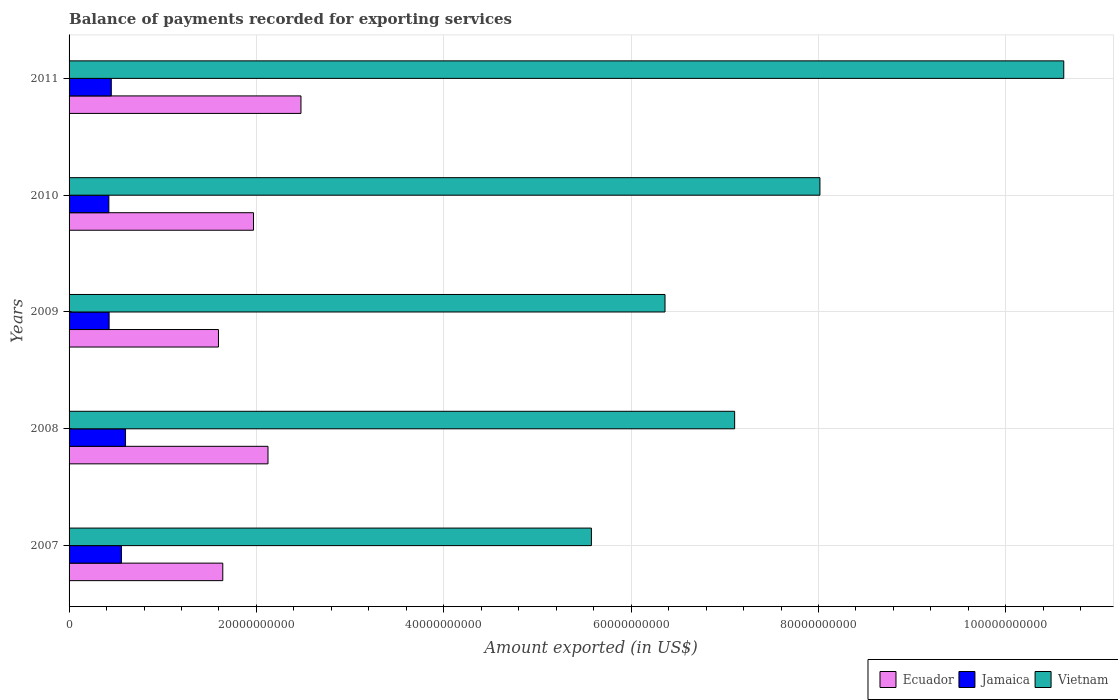How many different coloured bars are there?
Keep it short and to the point. 3. How many groups of bars are there?
Make the answer very short. 5. Are the number of bars on each tick of the Y-axis equal?
Provide a short and direct response. Yes. How many bars are there on the 3rd tick from the bottom?
Provide a succinct answer. 3. In how many cases, is the number of bars for a given year not equal to the number of legend labels?
Give a very brief answer. 0. What is the amount exported in Vietnam in 2011?
Make the answer very short. 1.06e+11. Across all years, what is the maximum amount exported in Ecuador?
Ensure brevity in your answer.  2.48e+1. Across all years, what is the minimum amount exported in Vietnam?
Provide a short and direct response. 5.58e+1. In which year was the amount exported in Ecuador maximum?
Provide a short and direct response. 2011. What is the total amount exported in Vietnam in the graph?
Offer a very short reply. 3.77e+11. What is the difference between the amount exported in Jamaica in 2008 and that in 2010?
Offer a very short reply. 1.78e+09. What is the difference between the amount exported in Ecuador in 2008 and the amount exported in Vietnam in 2007?
Provide a succinct answer. -3.45e+1. What is the average amount exported in Ecuador per year?
Offer a terse response. 1.96e+1. In the year 2009, what is the difference between the amount exported in Vietnam and amount exported in Ecuador?
Offer a terse response. 4.77e+1. What is the ratio of the amount exported in Jamaica in 2009 to that in 2010?
Your answer should be very brief. 1.01. Is the amount exported in Jamaica in 2009 less than that in 2011?
Ensure brevity in your answer.  Yes. Is the difference between the amount exported in Vietnam in 2009 and 2010 greater than the difference between the amount exported in Ecuador in 2009 and 2010?
Ensure brevity in your answer.  No. What is the difference between the highest and the second highest amount exported in Vietnam?
Your answer should be very brief. 2.60e+1. What is the difference between the highest and the lowest amount exported in Ecuador?
Provide a succinct answer. 8.81e+09. What does the 2nd bar from the top in 2011 represents?
Make the answer very short. Jamaica. What does the 3rd bar from the bottom in 2008 represents?
Make the answer very short. Vietnam. Is it the case that in every year, the sum of the amount exported in Ecuador and amount exported in Vietnam is greater than the amount exported in Jamaica?
Your response must be concise. Yes. How many bars are there?
Provide a succinct answer. 15. What is the difference between two consecutive major ticks on the X-axis?
Offer a terse response. 2.00e+1. Are the values on the major ticks of X-axis written in scientific E-notation?
Your response must be concise. No. Does the graph contain grids?
Provide a short and direct response. Yes. How many legend labels are there?
Provide a short and direct response. 3. How are the legend labels stacked?
Your response must be concise. Horizontal. What is the title of the graph?
Give a very brief answer. Balance of payments recorded for exporting services. What is the label or title of the X-axis?
Give a very brief answer. Amount exported (in US$). What is the label or title of the Y-axis?
Offer a very short reply. Years. What is the Amount exported (in US$) of Ecuador in 2007?
Ensure brevity in your answer.  1.64e+1. What is the Amount exported (in US$) in Jamaica in 2007?
Give a very brief answer. 5.59e+09. What is the Amount exported (in US$) in Vietnam in 2007?
Ensure brevity in your answer.  5.58e+1. What is the Amount exported (in US$) of Ecuador in 2008?
Offer a very short reply. 2.12e+1. What is the Amount exported (in US$) of Jamaica in 2008?
Provide a succinct answer. 6.03e+09. What is the Amount exported (in US$) of Vietnam in 2008?
Your answer should be compact. 7.10e+1. What is the Amount exported (in US$) in Ecuador in 2009?
Offer a very short reply. 1.59e+1. What is the Amount exported (in US$) of Jamaica in 2009?
Keep it short and to the point. 4.27e+09. What is the Amount exported (in US$) of Vietnam in 2009?
Keep it short and to the point. 6.36e+1. What is the Amount exported (in US$) of Ecuador in 2010?
Offer a terse response. 1.97e+1. What is the Amount exported (in US$) in Jamaica in 2010?
Your answer should be compact. 4.25e+09. What is the Amount exported (in US$) in Vietnam in 2010?
Your response must be concise. 8.02e+1. What is the Amount exported (in US$) in Ecuador in 2011?
Make the answer very short. 2.48e+1. What is the Amount exported (in US$) in Jamaica in 2011?
Your answer should be compact. 4.51e+09. What is the Amount exported (in US$) of Vietnam in 2011?
Offer a very short reply. 1.06e+11. Across all years, what is the maximum Amount exported (in US$) in Ecuador?
Your answer should be compact. 2.48e+1. Across all years, what is the maximum Amount exported (in US$) in Jamaica?
Make the answer very short. 6.03e+09. Across all years, what is the maximum Amount exported (in US$) of Vietnam?
Give a very brief answer. 1.06e+11. Across all years, what is the minimum Amount exported (in US$) of Ecuador?
Provide a short and direct response. 1.59e+1. Across all years, what is the minimum Amount exported (in US$) of Jamaica?
Your answer should be compact. 4.25e+09. Across all years, what is the minimum Amount exported (in US$) in Vietnam?
Make the answer very short. 5.58e+1. What is the total Amount exported (in US$) of Ecuador in the graph?
Give a very brief answer. 9.80e+1. What is the total Amount exported (in US$) in Jamaica in the graph?
Make the answer very short. 2.46e+1. What is the total Amount exported (in US$) of Vietnam in the graph?
Make the answer very short. 3.77e+11. What is the difference between the Amount exported (in US$) in Ecuador in 2007 and that in 2008?
Keep it short and to the point. -4.83e+09. What is the difference between the Amount exported (in US$) of Jamaica in 2007 and that in 2008?
Provide a short and direct response. -4.37e+08. What is the difference between the Amount exported (in US$) of Vietnam in 2007 and that in 2008?
Ensure brevity in your answer.  -1.53e+1. What is the difference between the Amount exported (in US$) of Ecuador in 2007 and that in 2009?
Your answer should be very brief. 4.60e+08. What is the difference between the Amount exported (in US$) of Jamaica in 2007 and that in 2009?
Ensure brevity in your answer.  1.32e+09. What is the difference between the Amount exported (in US$) in Vietnam in 2007 and that in 2009?
Provide a short and direct response. -7.86e+09. What is the difference between the Amount exported (in US$) of Ecuador in 2007 and that in 2010?
Keep it short and to the point. -3.28e+09. What is the difference between the Amount exported (in US$) of Jamaica in 2007 and that in 2010?
Provide a succinct answer. 1.34e+09. What is the difference between the Amount exported (in US$) in Vietnam in 2007 and that in 2010?
Keep it short and to the point. -2.44e+1. What is the difference between the Amount exported (in US$) of Ecuador in 2007 and that in 2011?
Provide a short and direct response. -8.35e+09. What is the difference between the Amount exported (in US$) in Jamaica in 2007 and that in 2011?
Offer a terse response. 1.08e+09. What is the difference between the Amount exported (in US$) in Vietnam in 2007 and that in 2011?
Your answer should be compact. -5.04e+1. What is the difference between the Amount exported (in US$) in Ecuador in 2008 and that in 2009?
Ensure brevity in your answer.  5.29e+09. What is the difference between the Amount exported (in US$) of Jamaica in 2008 and that in 2009?
Keep it short and to the point. 1.75e+09. What is the difference between the Amount exported (in US$) of Vietnam in 2008 and that in 2009?
Your response must be concise. 7.43e+09. What is the difference between the Amount exported (in US$) in Ecuador in 2008 and that in 2010?
Give a very brief answer. 1.55e+09. What is the difference between the Amount exported (in US$) of Jamaica in 2008 and that in 2010?
Keep it short and to the point. 1.78e+09. What is the difference between the Amount exported (in US$) in Vietnam in 2008 and that in 2010?
Your answer should be compact. -9.10e+09. What is the difference between the Amount exported (in US$) of Ecuador in 2008 and that in 2011?
Provide a short and direct response. -3.52e+09. What is the difference between the Amount exported (in US$) in Jamaica in 2008 and that in 2011?
Provide a short and direct response. 1.52e+09. What is the difference between the Amount exported (in US$) of Vietnam in 2008 and that in 2011?
Ensure brevity in your answer.  -3.51e+1. What is the difference between the Amount exported (in US$) of Ecuador in 2009 and that in 2010?
Keep it short and to the point. -3.74e+09. What is the difference between the Amount exported (in US$) of Jamaica in 2009 and that in 2010?
Provide a succinct answer. 2.57e+07. What is the difference between the Amount exported (in US$) of Vietnam in 2009 and that in 2010?
Your answer should be compact. -1.65e+1. What is the difference between the Amount exported (in US$) in Ecuador in 2009 and that in 2011?
Your response must be concise. -8.81e+09. What is the difference between the Amount exported (in US$) in Jamaica in 2009 and that in 2011?
Keep it short and to the point. -2.35e+08. What is the difference between the Amount exported (in US$) of Vietnam in 2009 and that in 2011?
Make the answer very short. -4.26e+1. What is the difference between the Amount exported (in US$) of Ecuador in 2010 and that in 2011?
Give a very brief answer. -5.07e+09. What is the difference between the Amount exported (in US$) in Jamaica in 2010 and that in 2011?
Your response must be concise. -2.60e+08. What is the difference between the Amount exported (in US$) of Vietnam in 2010 and that in 2011?
Make the answer very short. -2.60e+1. What is the difference between the Amount exported (in US$) in Ecuador in 2007 and the Amount exported (in US$) in Jamaica in 2008?
Offer a very short reply. 1.04e+1. What is the difference between the Amount exported (in US$) of Ecuador in 2007 and the Amount exported (in US$) of Vietnam in 2008?
Your answer should be very brief. -5.46e+1. What is the difference between the Amount exported (in US$) in Jamaica in 2007 and the Amount exported (in US$) in Vietnam in 2008?
Offer a terse response. -6.55e+1. What is the difference between the Amount exported (in US$) in Ecuador in 2007 and the Amount exported (in US$) in Jamaica in 2009?
Your answer should be very brief. 1.21e+1. What is the difference between the Amount exported (in US$) of Ecuador in 2007 and the Amount exported (in US$) of Vietnam in 2009?
Offer a terse response. -4.72e+1. What is the difference between the Amount exported (in US$) in Jamaica in 2007 and the Amount exported (in US$) in Vietnam in 2009?
Your answer should be very brief. -5.80e+1. What is the difference between the Amount exported (in US$) in Ecuador in 2007 and the Amount exported (in US$) in Jamaica in 2010?
Your answer should be very brief. 1.22e+1. What is the difference between the Amount exported (in US$) in Ecuador in 2007 and the Amount exported (in US$) in Vietnam in 2010?
Ensure brevity in your answer.  -6.37e+1. What is the difference between the Amount exported (in US$) in Jamaica in 2007 and the Amount exported (in US$) in Vietnam in 2010?
Keep it short and to the point. -7.46e+1. What is the difference between the Amount exported (in US$) in Ecuador in 2007 and the Amount exported (in US$) in Jamaica in 2011?
Ensure brevity in your answer.  1.19e+1. What is the difference between the Amount exported (in US$) in Ecuador in 2007 and the Amount exported (in US$) in Vietnam in 2011?
Offer a terse response. -8.98e+1. What is the difference between the Amount exported (in US$) of Jamaica in 2007 and the Amount exported (in US$) of Vietnam in 2011?
Offer a very short reply. -1.01e+11. What is the difference between the Amount exported (in US$) in Ecuador in 2008 and the Amount exported (in US$) in Jamaica in 2009?
Your response must be concise. 1.70e+1. What is the difference between the Amount exported (in US$) in Ecuador in 2008 and the Amount exported (in US$) in Vietnam in 2009?
Offer a very short reply. -4.24e+1. What is the difference between the Amount exported (in US$) in Jamaica in 2008 and the Amount exported (in US$) in Vietnam in 2009?
Your answer should be compact. -5.76e+1. What is the difference between the Amount exported (in US$) of Ecuador in 2008 and the Amount exported (in US$) of Jamaica in 2010?
Offer a very short reply. 1.70e+1. What is the difference between the Amount exported (in US$) of Ecuador in 2008 and the Amount exported (in US$) of Vietnam in 2010?
Keep it short and to the point. -5.89e+1. What is the difference between the Amount exported (in US$) of Jamaica in 2008 and the Amount exported (in US$) of Vietnam in 2010?
Offer a very short reply. -7.41e+1. What is the difference between the Amount exported (in US$) in Ecuador in 2008 and the Amount exported (in US$) in Jamaica in 2011?
Provide a short and direct response. 1.67e+1. What is the difference between the Amount exported (in US$) in Ecuador in 2008 and the Amount exported (in US$) in Vietnam in 2011?
Provide a succinct answer. -8.49e+1. What is the difference between the Amount exported (in US$) of Jamaica in 2008 and the Amount exported (in US$) of Vietnam in 2011?
Offer a terse response. -1.00e+11. What is the difference between the Amount exported (in US$) in Ecuador in 2009 and the Amount exported (in US$) in Jamaica in 2010?
Offer a terse response. 1.17e+1. What is the difference between the Amount exported (in US$) in Ecuador in 2009 and the Amount exported (in US$) in Vietnam in 2010?
Give a very brief answer. -6.42e+1. What is the difference between the Amount exported (in US$) in Jamaica in 2009 and the Amount exported (in US$) in Vietnam in 2010?
Keep it short and to the point. -7.59e+1. What is the difference between the Amount exported (in US$) of Ecuador in 2009 and the Amount exported (in US$) of Jamaica in 2011?
Provide a short and direct response. 1.14e+1. What is the difference between the Amount exported (in US$) in Ecuador in 2009 and the Amount exported (in US$) in Vietnam in 2011?
Provide a succinct answer. -9.02e+1. What is the difference between the Amount exported (in US$) in Jamaica in 2009 and the Amount exported (in US$) in Vietnam in 2011?
Offer a terse response. -1.02e+11. What is the difference between the Amount exported (in US$) of Ecuador in 2010 and the Amount exported (in US$) of Jamaica in 2011?
Provide a short and direct response. 1.52e+1. What is the difference between the Amount exported (in US$) in Ecuador in 2010 and the Amount exported (in US$) in Vietnam in 2011?
Your answer should be compact. -8.65e+1. What is the difference between the Amount exported (in US$) in Jamaica in 2010 and the Amount exported (in US$) in Vietnam in 2011?
Keep it short and to the point. -1.02e+11. What is the average Amount exported (in US$) in Ecuador per year?
Offer a terse response. 1.96e+1. What is the average Amount exported (in US$) of Jamaica per year?
Ensure brevity in your answer.  4.93e+09. What is the average Amount exported (in US$) in Vietnam per year?
Provide a short and direct response. 7.54e+1. In the year 2007, what is the difference between the Amount exported (in US$) of Ecuador and Amount exported (in US$) of Jamaica?
Make the answer very short. 1.08e+1. In the year 2007, what is the difference between the Amount exported (in US$) in Ecuador and Amount exported (in US$) in Vietnam?
Your answer should be compact. -3.93e+1. In the year 2007, what is the difference between the Amount exported (in US$) in Jamaica and Amount exported (in US$) in Vietnam?
Offer a terse response. -5.02e+1. In the year 2008, what is the difference between the Amount exported (in US$) in Ecuador and Amount exported (in US$) in Jamaica?
Make the answer very short. 1.52e+1. In the year 2008, what is the difference between the Amount exported (in US$) in Ecuador and Amount exported (in US$) in Vietnam?
Provide a short and direct response. -4.98e+1. In the year 2008, what is the difference between the Amount exported (in US$) of Jamaica and Amount exported (in US$) of Vietnam?
Provide a succinct answer. -6.50e+1. In the year 2009, what is the difference between the Amount exported (in US$) of Ecuador and Amount exported (in US$) of Jamaica?
Make the answer very short. 1.17e+1. In the year 2009, what is the difference between the Amount exported (in US$) in Ecuador and Amount exported (in US$) in Vietnam?
Keep it short and to the point. -4.77e+1. In the year 2009, what is the difference between the Amount exported (in US$) in Jamaica and Amount exported (in US$) in Vietnam?
Your answer should be very brief. -5.93e+1. In the year 2010, what is the difference between the Amount exported (in US$) of Ecuador and Amount exported (in US$) of Jamaica?
Offer a very short reply. 1.54e+1. In the year 2010, what is the difference between the Amount exported (in US$) of Ecuador and Amount exported (in US$) of Vietnam?
Provide a succinct answer. -6.05e+1. In the year 2010, what is the difference between the Amount exported (in US$) of Jamaica and Amount exported (in US$) of Vietnam?
Give a very brief answer. -7.59e+1. In the year 2011, what is the difference between the Amount exported (in US$) in Ecuador and Amount exported (in US$) in Jamaica?
Keep it short and to the point. 2.02e+1. In the year 2011, what is the difference between the Amount exported (in US$) of Ecuador and Amount exported (in US$) of Vietnam?
Ensure brevity in your answer.  -8.14e+1. In the year 2011, what is the difference between the Amount exported (in US$) in Jamaica and Amount exported (in US$) in Vietnam?
Your answer should be very brief. -1.02e+11. What is the ratio of the Amount exported (in US$) of Ecuador in 2007 to that in 2008?
Provide a succinct answer. 0.77. What is the ratio of the Amount exported (in US$) of Jamaica in 2007 to that in 2008?
Your response must be concise. 0.93. What is the ratio of the Amount exported (in US$) in Vietnam in 2007 to that in 2008?
Give a very brief answer. 0.78. What is the ratio of the Amount exported (in US$) of Ecuador in 2007 to that in 2009?
Offer a terse response. 1.03. What is the ratio of the Amount exported (in US$) in Jamaica in 2007 to that in 2009?
Offer a terse response. 1.31. What is the ratio of the Amount exported (in US$) in Vietnam in 2007 to that in 2009?
Your answer should be compact. 0.88. What is the ratio of the Amount exported (in US$) in Ecuador in 2007 to that in 2010?
Make the answer very short. 0.83. What is the ratio of the Amount exported (in US$) of Jamaica in 2007 to that in 2010?
Give a very brief answer. 1.32. What is the ratio of the Amount exported (in US$) in Vietnam in 2007 to that in 2010?
Make the answer very short. 0.7. What is the ratio of the Amount exported (in US$) of Ecuador in 2007 to that in 2011?
Your response must be concise. 0.66. What is the ratio of the Amount exported (in US$) of Jamaica in 2007 to that in 2011?
Provide a short and direct response. 1.24. What is the ratio of the Amount exported (in US$) of Vietnam in 2007 to that in 2011?
Your response must be concise. 0.53. What is the ratio of the Amount exported (in US$) in Ecuador in 2008 to that in 2009?
Offer a very short reply. 1.33. What is the ratio of the Amount exported (in US$) of Jamaica in 2008 to that in 2009?
Your answer should be very brief. 1.41. What is the ratio of the Amount exported (in US$) in Vietnam in 2008 to that in 2009?
Your answer should be very brief. 1.12. What is the ratio of the Amount exported (in US$) of Ecuador in 2008 to that in 2010?
Give a very brief answer. 1.08. What is the ratio of the Amount exported (in US$) in Jamaica in 2008 to that in 2010?
Provide a short and direct response. 1.42. What is the ratio of the Amount exported (in US$) of Vietnam in 2008 to that in 2010?
Offer a very short reply. 0.89. What is the ratio of the Amount exported (in US$) in Ecuador in 2008 to that in 2011?
Give a very brief answer. 0.86. What is the ratio of the Amount exported (in US$) of Jamaica in 2008 to that in 2011?
Provide a short and direct response. 1.34. What is the ratio of the Amount exported (in US$) of Vietnam in 2008 to that in 2011?
Make the answer very short. 0.67. What is the ratio of the Amount exported (in US$) of Ecuador in 2009 to that in 2010?
Offer a very short reply. 0.81. What is the ratio of the Amount exported (in US$) in Vietnam in 2009 to that in 2010?
Make the answer very short. 0.79. What is the ratio of the Amount exported (in US$) in Ecuador in 2009 to that in 2011?
Your answer should be compact. 0.64. What is the ratio of the Amount exported (in US$) in Jamaica in 2009 to that in 2011?
Keep it short and to the point. 0.95. What is the ratio of the Amount exported (in US$) of Vietnam in 2009 to that in 2011?
Offer a terse response. 0.6. What is the ratio of the Amount exported (in US$) of Ecuador in 2010 to that in 2011?
Ensure brevity in your answer.  0.8. What is the ratio of the Amount exported (in US$) of Jamaica in 2010 to that in 2011?
Your answer should be very brief. 0.94. What is the ratio of the Amount exported (in US$) in Vietnam in 2010 to that in 2011?
Give a very brief answer. 0.75. What is the difference between the highest and the second highest Amount exported (in US$) in Ecuador?
Your response must be concise. 3.52e+09. What is the difference between the highest and the second highest Amount exported (in US$) in Jamaica?
Make the answer very short. 4.37e+08. What is the difference between the highest and the second highest Amount exported (in US$) in Vietnam?
Your answer should be very brief. 2.60e+1. What is the difference between the highest and the lowest Amount exported (in US$) of Ecuador?
Ensure brevity in your answer.  8.81e+09. What is the difference between the highest and the lowest Amount exported (in US$) of Jamaica?
Provide a succinct answer. 1.78e+09. What is the difference between the highest and the lowest Amount exported (in US$) in Vietnam?
Your answer should be very brief. 5.04e+1. 